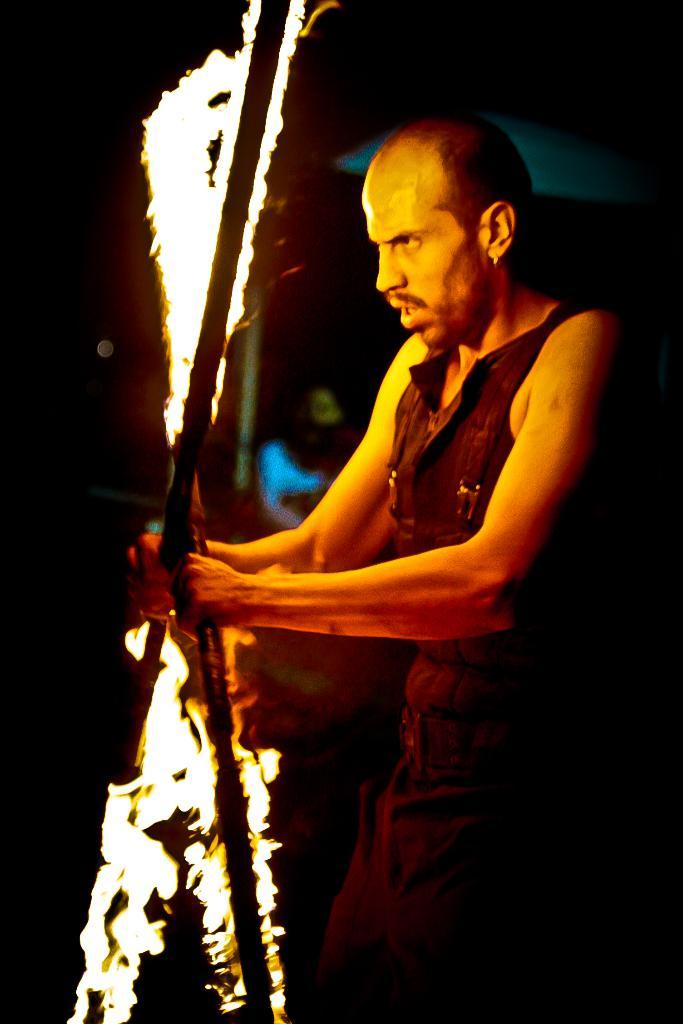What is present in the image? There is a man in the image. What is the man doing in the image? The man is standing on the ground and holding sticks with fire. Can you describe the man's position in relation to the ground? The man is standing on the ground. What type of crib can be seen in the image? There is no crib present in the image. What things can be seen in the image? The image only shows a man standing on the ground and holding sticks with fire. 